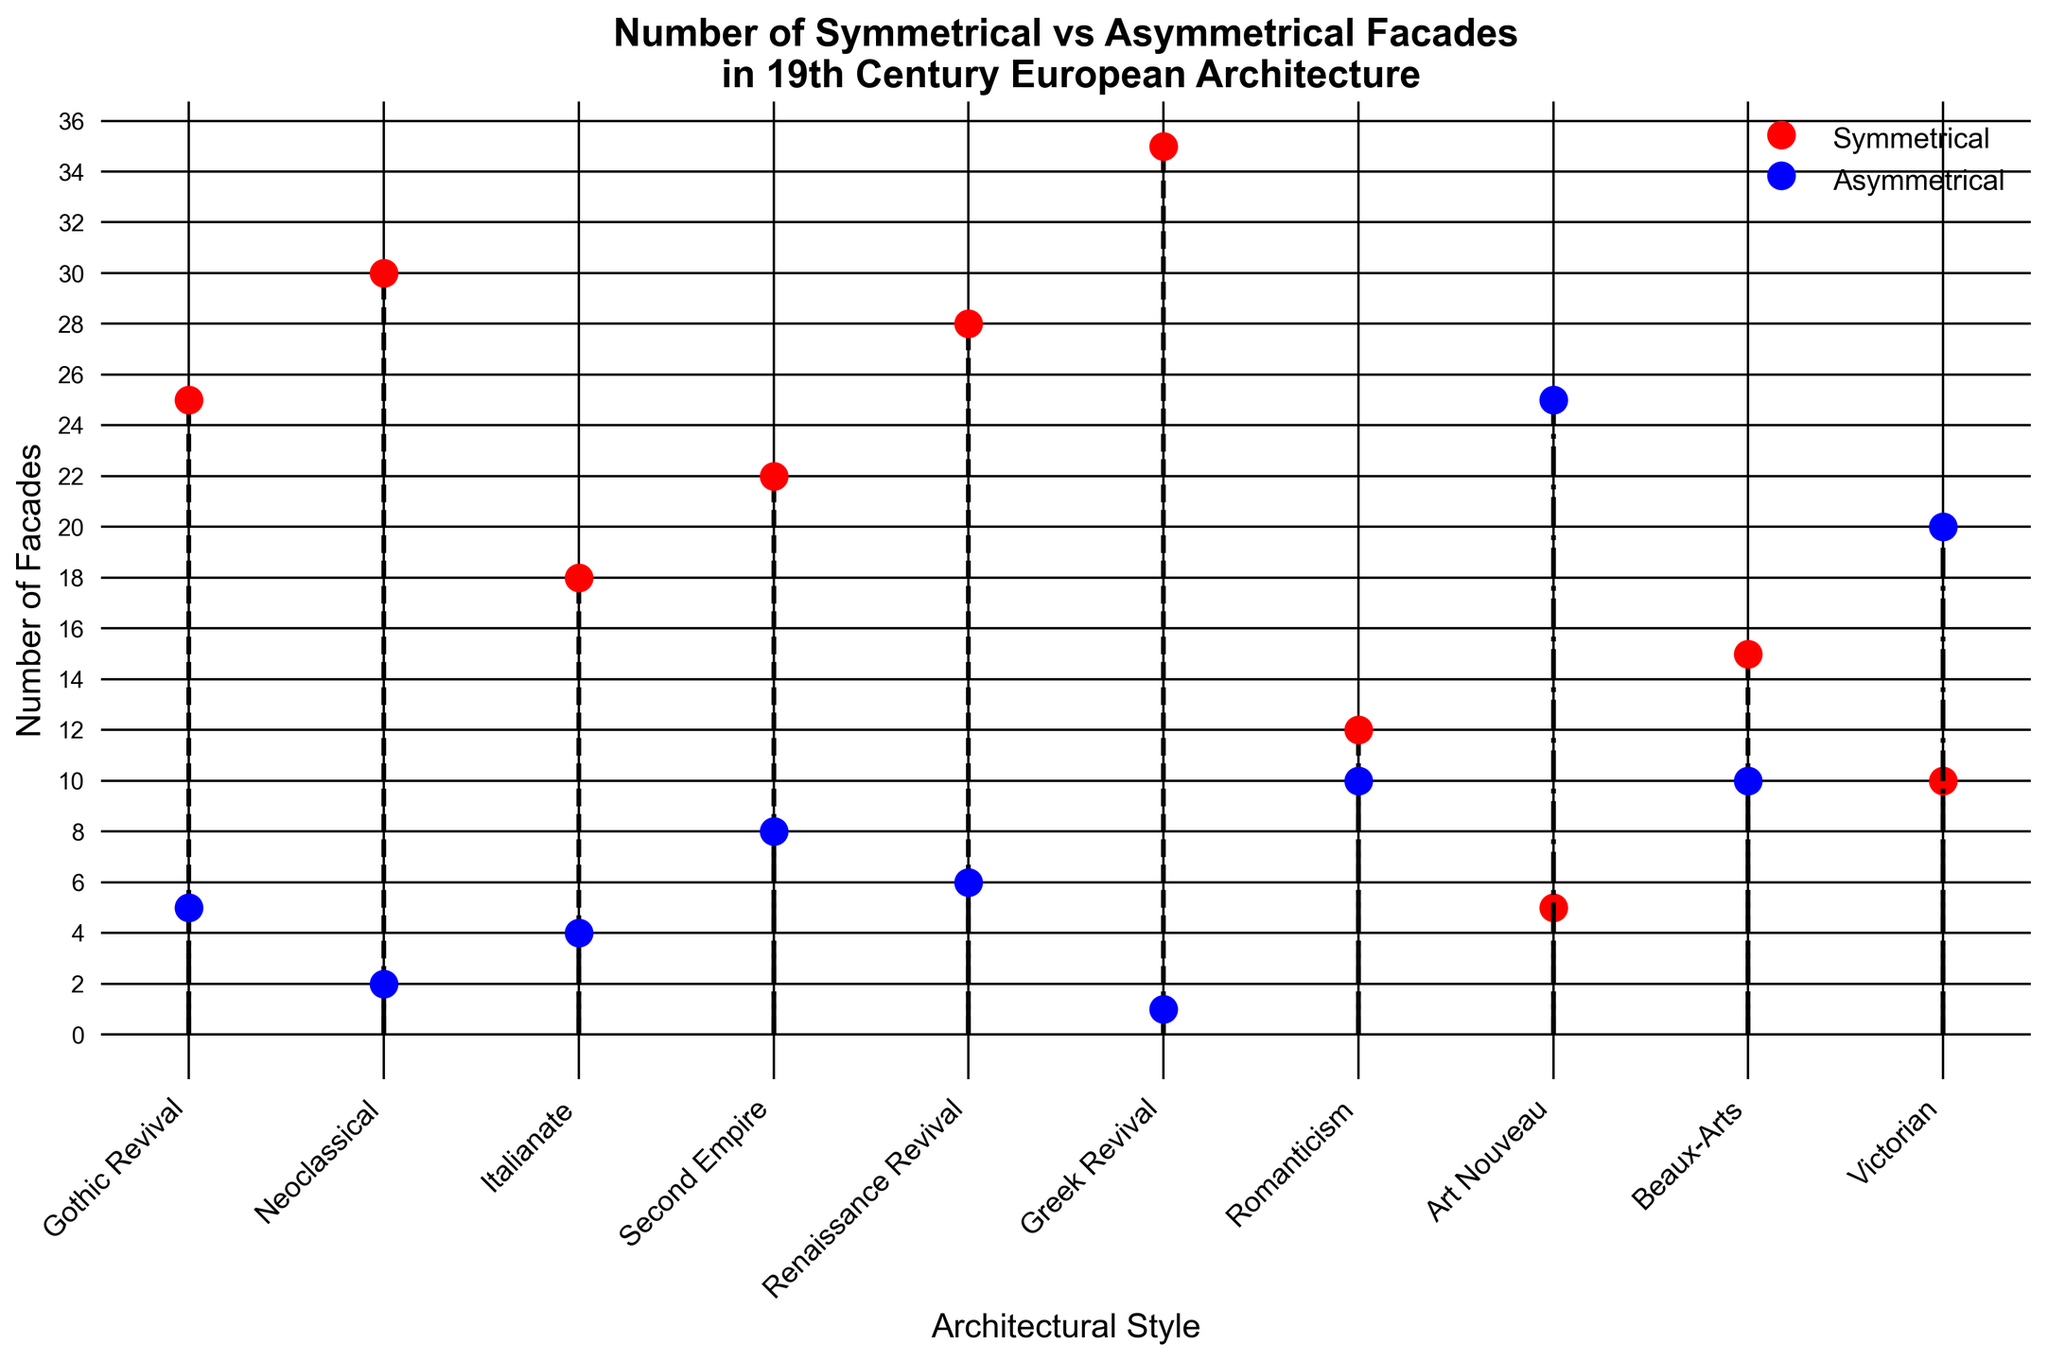Which architectural style has the highest number of symmetrical facades? Look at the red markers representing symmetrical facades. Find the highest point, which corresponds to Greek Revival.
Answer: Greek Revival Which style shows a predominance of asymmetrical facades over symmetrical facades? Look at the blue markers representing asymmetrical facades and compare them to the red markers for the same style. Identify the one(s) with higher blue markers: Art Nouveau and Victorian.
Answer: Art Nouveau and Victorian How many architectural styles have more than 20 symmetrical facades? Count the red markers above 20: Gothic Revival, Neoclassical, Second Empire, Renaissance Revival, and Greek Revival.
Answer: 5 Compare the Gothic Revival and Italianate styles in terms of symmetrical facades. Which has more and by how much? Find the red markers for Gothic Revival (25) and Italianate (18). Subtract the number for Italianate from Gothic Revival: 25 - 18 = 7.
Answer: Gothic Revival has 7 more symmetrical facades What is the total number of asymmetrical facades in Romanticism, Art Nouveau, and Beaux-Arts? Look at the blue markers for Romanticism (10), Art Nouveau (25), and Beaux-Arts (10). Sum them: 10 + 25 + 10 = 45.
Answer: 45 Which architectural style has the second-highest number of asymmetrical facades? Compare the heights of the blue markers and identify the second-tallest, which corresponds to Victorian (20).
Answer: Victorian Is the total number of symmetrical facades greater than the total number of asymmetrical facades? Sum all red markers (25+30+18+22+28+35+12+5+15+10 = 200) and blue markers (5+2+4+8+6+1+10+25+10+20 = 91). Compare totals: 200 > 91.
Answer: Yes What is the average number of symmetrical facades across all styles? Sum all red markers (200) and divide by the number of styles (10): 200 / 10 = 20.
Answer: 20 Which architectural style has the smallest difference between its number of symmetrical and asymmetrical facades? Find differences for each style: Gothic Revival (20), Neoclassical (28), Italianate (14), Second Empire (14), Renaissance Revival (22), Greek Revival (34), Romanticism (2), Art Nouveau (20), Beaux-Arts (5), Victorian (10). Smallest is Romanticism (2).
Answer: Romanticism 